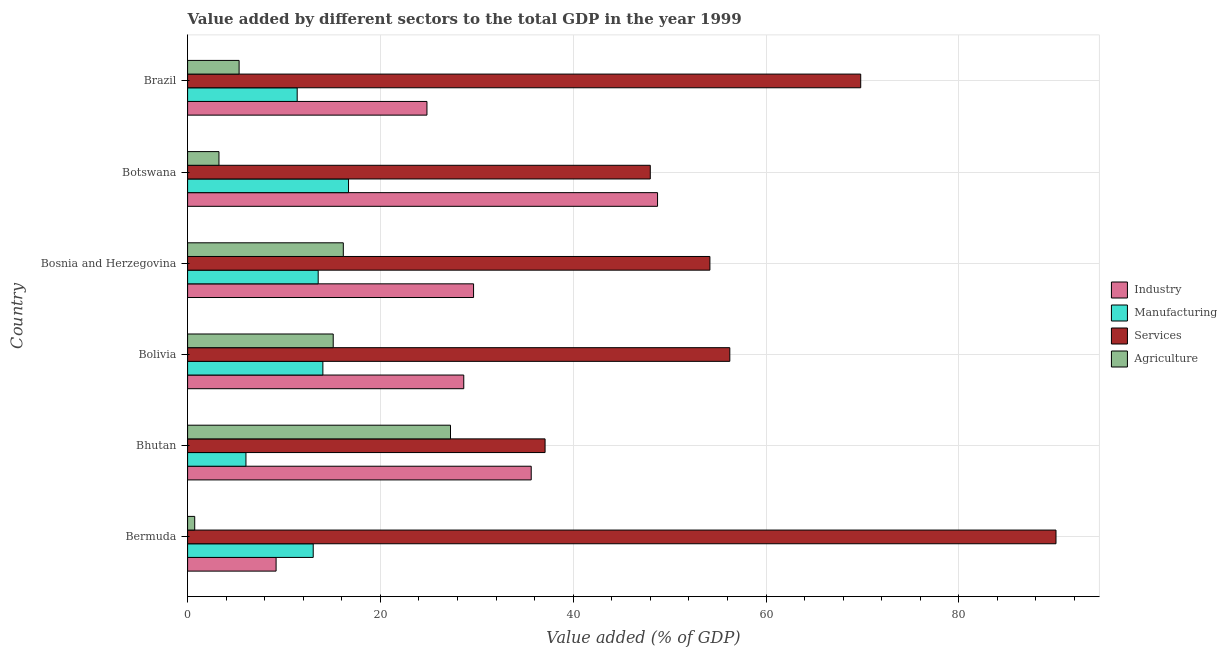How many different coloured bars are there?
Provide a short and direct response. 4. How many groups of bars are there?
Offer a terse response. 6. Are the number of bars on each tick of the Y-axis equal?
Provide a succinct answer. Yes. How many bars are there on the 3rd tick from the top?
Your answer should be compact. 4. What is the label of the 6th group of bars from the top?
Your response must be concise. Bermuda. In how many cases, is the number of bars for a given country not equal to the number of legend labels?
Ensure brevity in your answer.  0. What is the value added by services sector in Bermuda?
Give a very brief answer. 90.08. Across all countries, what is the maximum value added by industrial sector?
Your response must be concise. 48.75. Across all countries, what is the minimum value added by services sector?
Your response must be concise. 37.08. In which country was the value added by industrial sector maximum?
Offer a terse response. Botswana. In which country was the value added by industrial sector minimum?
Your response must be concise. Bermuda. What is the total value added by services sector in the graph?
Your response must be concise. 355.41. What is the difference between the value added by manufacturing sector in Bermuda and that in Brazil?
Offer a terse response. 1.66. What is the difference between the value added by industrial sector in Botswana and the value added by manufacturing sector in Bhutan?
Offer a very short reply. 42.7. What is the average value added by manufacturing sector per country?
Offer a very short reply. 12.46. What is the difference between the value added by industrial sector and value added by manufacturing sector in Brazil?
Provide a short and direct response. 13.46. What is the ratio of the value added by agricultural sector in Bhutan to that in Brazil?
Your answer should be compact. 5.1. What is the difference between the highest and the second highest value added by industrial sector?
Offer a very short reply. 13.11. What is the difference between the highest and the lowest value added by agricultural sector?
Your answer should be very brief. 26.53. In how many countries, is the value added by industrial sector greater than the average value added by industrial sector taken over all countries?
Provide a short and direct response. 3. Is the sum of the value added by services sector in Bhutan and Bolivia greater than the maximum value added by industrial sector across all countries?
Keep it short and to the point. Yes. Is it the case that in every country, the sum of the value added by services sector and value added by agricultural sector is greater than the sum of value added by industrial sector and value added by manufacturing sector?
Provide a succinct answer. Yes. What does the 1st bar from the top in Bermuda represents?
Provide a short and direct response. Agriculture. What does the 2nd bar from the bottom in Bhutan represents?
Provide a short and direct response. Manufacturing. Are all the bars in the graph horizontal?
Your answer should be very brief. Yes. How many countries are there in the graph?
Offer a very short reply. 6. Are the values on the major ticks of X-axis written in scientific E-notation?
Your answer should be very brief. No. Does the graph contain any zero values?
Your answer should be compact. No. Does the graph contain grids?
Ensure brevity in your answer.  Yes. How are the legend labels stacked?
Provide a short and direct response. Vertical. What is the title of the graph?
Your response must be concise. Value added by different sectors to the total GDP in the year 1999. What is the label or title of the X-axis?
Your answer should be very brief. Value added (% of GDP). What is the Value added (% of GDP) in Industry in Bermuda?
Make the answer very short. 9.18. What is the Value added (% of GDP) in Manufacturing in Bermuda?
Offer a very short reply. 13.03. What is the Value added (% of GDP) in Services in Bermuda?
Provide a succinct answer. 90.08. What is the Value added (% of GDP) of Agriculture in Bermuda?
Make the answer very short. 0.74. What is the Value added (% of GDP) in Industry in Bhutan?
Make the answer very short. 35.65. What is the Value added (% of GDP) in Manufacturing in Bhutan?
Make the answer very short. 6.05. What is the Value added (% of GDP) of Services in Bhutan?
Offer a very short reply. 37.08. What is the Value added (% of GDP) of Agriculture in Bhutan?
Your answer should be very brief. 27.27. What is the Value added (% of GDP) of Industry in Bolivia?
Make the answer very short. 28.65. What is the Value added (% of GDP) of Manufacturing in Bolivia?
Offer a very short reply. 14.03. What is the Value added (% of GDP) of Services in Bolivia?
Your answer should be compact. 56.25. What is the Value added (% of GDP) of Agriculture in Bolivia?
Offer a very short reply. 15.11. What is the Value added (% of GDP) in Industry in Bosnia and Herzegovina?
Make the answer very short. 29.66. What is the Value added (% of GDP) of Manufacturing in Bosnia and Herzegovina?
Your response must be concise. 13.55. What is the Value added (% of GDP) in Services in Bosnia and Herzegovina?
Offer a terse response. 54.18. What is the Value added (% of GDP) in Agriculture in Bosnia and Herzegovina?
Provide a short and direct response. 16.15. What is the Value added (% of GDP) of Industry in Botswana?
Provide a succinct answer. 48.75. What is the Value added (% of GDP) of Manufacturing in Botswana?
Offer a terse response. 16.69. What is the Value added (% of GDP) of Services in Botswana?
Make the answer very short. 48. What is the Value added (% of GDP) of Agriculture in Botswana?
Offer a terse response. 3.25. What is the Value added (% of GDP) in Industry in Brazil?
Provide a succinct answer. 24.83. What is the Value added (% of GDP) in Manufacturing in Brazil?
Give a very brief answer. 11.37. What is the Value added (% of GDP) in Services in Brazil?
Your answer should be very brief. 69.83. What is the Value added (% of GDP) of Agriculture in Brazil?
Your response must be concise. 5.34. Across all countries, what is the maximum Value added (% of GDP) of Industry?
Offer a very short reply. 48.75. Across all countries, what is the maximum Value added (% of GDP) of Manufacturing?
Provide a short and direct response. 16.69. Across all countries, what is the maximum Value added (% of GDP) of Services?
Your answer should be very brief. 90.08. Across all countries, what is the maximum Value added (% of GDP) of Agriculture?
Provide a short and direct response. 27.27. Across all countries, what is the minimum Value added (% of GDP) in Industry?
Provide a succinct answer. 9.18. Across all countries, what is the minimum Value added (% of GDP) of Manufacturing?
Offer a very short reply. 6.05. Across all countries, what is the minimum Value added (% of GDP) of Services?
Make the answer very short. 37.08. Across all countries, what is the minimum Value added (% of GDP) in Agriculture?
Offer a terse response. 0.74. What is the total Value added (% of GDP) of Industry in the graph?
Your response must be concise. 176.72. What is the total Value added (% of GDP) in Manufacturing in the graph?
Your response must be concise. 74.73. What is the total Value added (% of GDP) of Services in the graph?
Offer a very short reply. 355.41. What is the total Value added (% of GDP) of Agriculture in the graph?
Give a very brief answer. 67.87. What is the difference between the Value added (% of GDP) of Industry in Bermuda and that in Bhutan?
Provide a succinct answer. -26.47. What is the difference between the Value added (% of GDP) in Manufacturing in Bermuda and that in Bhutan?
Provide a succinct answer. 6.98. What is the difference between the Value added (% of GDP) of Services in Bermuda and that in Bhutan?
Ensure brevity in your answer.  53. What is the difference between the Value added (% of GDP) in Agriculture in Bermuda and that in Bhutan?
Your answer should be very brief. -26.53. What is the difference between the Value added (% of GDP) in Industry in Bermuda and that in Bolivia?
Provide a succinct answer. -19.47. What is the difference between the Value added (% of GDP) in Manufacturing in Bermuda and that in Bolivia?
Offer a very short reply. -1. What is the difference between the Value added (% of GDP) in Services in Bermuda and that in Bolivia?
Keep it short and to the point. 33.84. What is the difference between the Value added (% of GDP) of Agriculture in Bermuda and that in Bolivia?
Keep it short and to the point. -14.37. What is the difference between the Value added (% of GDP) in Industry in Bermuda and that in Bosnia and Herzegovina?
Provide a short and direct response. -20.49. What is the difference between the Value added (% of GDP) in Manufacturing in Bermuda and that in Bosnia and Herzegovina?
Ensure brevity in your answer.  -0.51. What is the difference between the Value added (% of GDP) of Services in Bermuda and that in Bosnia and Herzegovina?
Provide a succinct answer. 35.9. What is the difference between the Value added (% of GDP) in Agriculture in Bermuda and that in Bosnia and Herzegovina?
Ensure brevity in your answer.  -15.41. What is the difference between the Value added (% of GDP) in Industry in Bermuda and that in Botswana?
Offer a very short reply. -39.57. What is the difference between the Value added (% of GDP) in Manufacturing in Bermuda and that in Botswana?
Keep it short and to the point. -3.66. What is the difference between the Value added (% of GDP) in Services in Bermuda and that in Botswana?
Give a very brief answer. 42.09. What is the difference between the Value added (% of GDP) in Agriculture in Bermuda and that in Botswana?
Offer a terse response. -2.52. What is the difference between the Value added (% of GDP) in Industry in Bermuda and that in Brazil?
Your response must be concise. -15.65. What is the difference between the Value added (% of GDP) of Manufacturing in Bermuda and that in Brazil?
Provide a succinct answer. 1.66. What is the difference between the Value added (% of GDP) in Services in Bermuda and that in Brazil?
Your answer should be very brief. 20.26. What is the difference between the Value added (% of GDP) in Agriculture in Bermuda and that in Brazil?
Offer a very short reply. -4.61. What is the difference between the Value added (% of GDP) in Industry in Bhutan and that in Bolivia?
Give a very brief answer. 7. What is the difference between the Value added (% of GDP) in Manufacturing in Bhutan and that in Bolivia?
Keep it short and to the point. -7.98. What is the difference between the Value added (% of GDP) of Services in Bhutan and that in Bolivia?
Your answer should be very brief. -19.16. What is the difference between the Value added (% of GDP) in Agriculture in Bhutan and that in Bolivia?
Ensure brevity in your answer.  12.17. What is the difference between the Value added (% of GDP) in Industry in Bhutan and that in Bosnia and Herzegovina?
Your answer should be very brief. 5.98. What is the difference between the Value added (% of GDP) of Manufacturing in Bhutan and that in Bosnia and Herzegovina?
Make the answer very short. -7.49. What is the difference between the Value added (% of GDP) of Services in Bhutan and that in Bosnia and Herzegovina?
Your answer should be very brief. -17.1. What is the difference between the Value added (% of GDP) in Agriculture in Bhutan and that in Bosnia and Herzegovina?
Provide a short and direct response. 11.12. What is the difference between the Value added (% of GDP) of Industry in Bhutan and that in Botswana?
Your answer should be compact. -13.11. What is the difference between the Value added (% of GDP) in Manufacturing in Bhutan and that in Botswana?
Make the answer very short. -10.64. What is the difference between the Value added (% of GDP) in Services in Bhutan and that in Botswana?
Provide a succinct answer. -10.91. What is the difference between the Value added (% of GDP) of Agriculture in Bhutan and that in Botswana?
Ensure brevity in your answer.  24.02. What is the difference between the Value added (% of GDP) in Industry in Bhutan and that in Brazil?
Offer a very short reply. 10.82. What is the difference between the Value added (% of GDP) of Manufacturing in Bhutan and that in Brazil?
Offer a terse response. -5.32. What is the difference between the Value added (% of GDP) in Services in Bhutan and that in Brazil?
Your response must be concise. -32.74. What is the difference between the Value added (% of GDP) of Agriculture in Bhutan and that in Brazil?
Provide a succinct answer. 21.93. What is the difference between the Value added (% of GDP) in Industry in Bolivia and that in Bosnia and Herzegovina?
Provide a short and direct response. -1.02. What is the difference between the Value added (% of GDP) of Manufacturing in Bolivia and that in Bosnia and Herzegovina?
Provide a short and direct response. 0.49. What is the difference between the Value added (% of GDP) in Services in Bolivia and that in Bosnia and Herzegovina?
Your response must be concise. 2.06. What is the difference between the Value added (% of GDP) in Agriculture in Bolivia and that in Bosnia and Herzegovina?
Offer a very short reply. -1.05. What is the difference between the Value added (% of GDP) of Industry in Bolivia and that in Botswana?
Give a very brief answer. -20.1. What is the difference between the Value added (% of GDP) of Manufacturing in Bolivia and that in Botswana?
Offer a terse response. -2.66. What is the difference between the Value added (% of GDP) of Services in Bolivia and that in Botswana?
Your answer should be very brief. 8.25. What is the difference between the Value added (% of GDP) in Agriculture in Bolivia and that in Botswana?
Your answer should be compact. 11.85. What is the difference between the Value added (% of GDP) of Industry in Bolivia and that in Brazil?
Ensure brevity in your answer.  3.82. What is the difference between the Value added (% of GDP) in Manufacturing in Bolivia and that in Brazil?
Offer a very short reply. 2.66. What is the difference between the Value added (% of GDP) in Services in Bolivia and that in Brazil?
Ensure brevity in your answer.  -13.58. What is the difference between the Value added (% of GDP) of Agriculture in Bolivia and that in Brazil?
Make the answer very short. 9.76. What is the difference between the Value added (% of GDP) in Industry in Bosnia and Herzegovina and that in Botswana?
Your answer should be very brief. -19.09. What is the difference between the Value added (% of GDP) of Manufacturing in Bosnia and Herzegovina and that in Botswana?
Keep it short and to the point. -3.15. What is the difference between the Value added (% of GDP) in Services in Bosnia and Herzegovina and that in Botswana?
Your response must be concise. 6.19. What is the difference between the Value added (% of GDP) in Agriculture in Bosnia and Herzegovina and that in Botswana?
Provide a succinct answer. 12.9. What is the difference between the Value added (% of GDP) in Industry in Bosnia and Herzegovina and that in Brazil?
Your answer should be very brief. 4.83. What is the difference between the Value added (% of GDP) of Manufacturing in Bosnia and Herzegovina and that in Brazil?
Your response must be concise. 2.18. What is the difference between the Value added (% of GDP) in Services in Bosnia and Herzegovina and that in Brazil?
Give a very brief answer. -15.64. What is the difference between the Value added (% of GDP) in Agriculture in Bosnia and Herzegovina and that in Brazil?
Your response must be concise. 10.81. What is the difference between the Value added (% of GDP) in Industry in Botswana and that in Brazil?
Give a very brief answer. 23.92. What is the difference between the Value added (% of GDP) of Manufacturing in Botswana and that in Brazil?
Keep it short and to the point. 5.33. What is the difference between the Value added (% of GDP) in Services in Botswana and that in Brazil?
Ensure brevity in your answer.  -21.83. What is the difference between the Value added (% of GDP) of Agriculture in Botswana and that in Brazil?
Provide a short and direct response. -2.09. What is the difference between the Value added (% of GDP) in Industry in Bermuda and the Value added (% of GDP) in Manufacturing in Bhutan?
Your answer should be compact. 3.13. What is the difference between the Value added (% of GDP) of Industry in Bermuda and the Value added (% of GDP) of Services in Bhutan?
Ensure brevity in your answer.  -27.9. What is the difference between the Value added (% of GDP) of Industry in Bermuda and the Value added (% of GDP) of Agriculture in Bhutan?
Provide a short and direct response. -18.09. What is the difference between the Value added (% of GDP) of Manufacturing in Bermuda and the Value added (% of GDP) of Services in Bhutan?
Offer a very short reply. -24.05. What is the difference between the Value added (% of GDP) of Manufacturing in Bermuda and the Value added (% of GDP) of Agriculture in Bhutan?
Keep it short and to the point. -14.24. What is the difference between the Value added (% of GDP) of Services in Bermuda and the Value added (% of GDP) of Agriculture in Bhutan?
Your answer should be very brief. 62.81. What is the difference between the Value added (% of GDP) of Industry in Bermuda and the Value added (% of GDP) of Manufacturing in Bolivia?
Your response must be concise. -4.85. What is the difference between the Value added (% of GDP) of Industry in Bermuda and the Value added (% of GDP) of Services in Bolivia?
Provide a short and direct response. -47.07. What is the difference between the Value added (% of GDP) in Industry in Bermuda and the Value added (% of GDP) in Agriculture in Bolivia?
Provide a succinct answer. -5.93. What is the difference between the Value added (% of GDP) in Manufacturing in Bermuda and the Value added (% of GDP) in Services in Bolivia?
Your answer should be compact. -43.21. What is the difference between the Value added (% of GDP) of Manufacturing in Bermuda and the Value added (% of GDP) of Agriculture in Bolivia?
Offer a very short reply. -2.07. What is the difference between the Value added (% of GDP) of Services in Bermuda and the Value added (% of GDP) of Agriculture in Bolivia?
Give a very brief answer. 74.98. What is the difference between the Value added (% of GDP) in Industry in Bermuda and the Value added (% of GDP) in Manufacturing in Bosnia and Herzegovina?
Provide a succinct answer. -4.37. What is the difference between the Value added (% of GDP) in Industry in Bermuda and the Value added (% of GDP) in Services in Bosnia and Herzegovina?
Your answer should be compact. -45. What is the difference between the Value added (% of GDP) in Industry in Bermuda and the Value added (% of GDP) in Agriculture in Bosnia and Herzegovina?
Make the answer very short. -6.97. What is the difference between the Value added (% of GDP) of Manufacturing in Bermuda and the Value added (% of GDP) of Services in Bosnia and Herzegovina?
Keep it short and to the point. -41.15. What is the difference between the Value added (% of GDP) of Manufacturing in Bermuda and the Value added (% of GDP) of Agriculture in Bosnia and Herzegovina?
Your response must be concise. -3.12. What is the difference between the Value added (% of GDP) in Services in Bermuda and the Value added (% of GDP) in Agriculture in Bosnia and Herzegovina?
Give a very brief answer. 73.93. What is the difference between the Value added (% of GDP) in Industry in Bermuda and the Value added (% of GDP) in Manufacturing in Botswana?
Your response must be concise. -7.51. What is the difference between the Value added (% of GDP) in Industry in Bermuda and the Value added (% of GDP) in Services in Botswana?
Keep it short and to the point. -38.82. What is the difference between the Value added (% of GDP) of Industry in Bermuda and the Value added (% of GDP) of Agriculture in Botswana?
Keep it short and to the point. 5.93. What is the difference between the Value added (% of GDP) of Manufacturing in Bermuda and the Value added (% of GDP) of Services in Botswana?
Keep it short and to the point. -34.96. What is the difference between the Value added (% of GDP) in Manufacturing in Bermuda and the Value added (% of GDP) in Agriculture in Botswana?
Your answer should be compact. 9.78. What is the difference between the Value added (% of GDP) of Services in Bermuda and the Value added (% of GDP) of Agriculture in Botswana?
Provide a succinct answer. 86.83. What is the difference between the Value added (% of GDP) in Industry in Bermuda and the Value added (% of GDP) in Manufacturing in Brazil?
Give a very brief answer. -2.19. What is the difference between the Value added (% of GDP) of Industry in Bermuda and the Value added (% of GDP) of Services in Brazil?
Give a very brief answer. -60.65. What is the difference between the Value added (% of GDP) in Industry in Bermuda and the Value added (% of GDP) in Agriculture in Brazil?
Ensure brevity in your answer.  3.84. What is the difference between the Value added (% of GDP) in Manufacturing in Bermuda and the Value added (% of GDP) in Services in Brazil?
Offer a terse response. -56.79. What is the difference between the Value added (% of GDP) of Manufacturing in Bermuda and the Value added (% of GDP) of Agriculture in Brazil?
Keep it short and to the point. 7.69. What is the difference between the Value added (% of GDP) of Services in Bermuda and the Value added (% of GDP) of Agriculture in Brazil?
Offer a terse response. 84.74. What is the difference between the Value added (% of GDP) of Industry in Bhutan and the Value added (% of GDP) of Manufacturing in Bolivia?
Make the answer very short. 21.61. What is the difference between the Value added (% of GDP) of Industry in Bhutan and the Value added (% of GDP) of Services in Bolivia?
Give a very brief answer. -20.6. What is the difference between the Value added (% of GDP) in Industry in Bhutan and the Value added (% of GDP) in Agriculture in Bolivia?
Your answer should be very brief. 20.54. What is the difference between the Value added (% of GDP) in Manufacturing in Bhutan and the Value added (% of GDP) in Services in Bolivia?
Provide a short and direct response. -50.19. What is the difference between the Value added (% of GDP) of Manufacturing in Bhutan and the Value added (% of GDP) of Agriculture in Bolivia?
Your answer should be very brief. -9.05. What is the difference between the Value added (% of GDP) in Services in Bhutan and the Value added (% of GDP) in Agriculture in Bolivia?
Your answer should be very brief. 21.98. What is the difference between the Value added (% of GDP) in Industry in Bhutan and the Value added (% of GDP) in Manufacturing in Bosnia and Herzegovina?
Provide a succinct answer. 22.1. What is the difference between the Value added (% of GDP) in Industry in Bhutan and the Value added (% of GDP) in Services in Bosnia and Herzegovina?
Provide a succinct answer. -18.54. What is the difference between the Value added (% of GDP) of Industry in Bhutan and the Value added (% of GDP) of Agriculture in Bosnia and Herzegovina?
Offer a very short reply. 19.49. What is the difference between the Value added (% of GDP) in Manufacturing in Bhutan and the Value added (% of GDP) in Services in Bosnia and Herzegovina?
Make the answer very short. -48.13. What is the difference between the Value added (% of GDP) of Manufacturing in Bhutan and the Value added (% of GDP) of Agriculture in Bosnia and Herzegovina?
Offer a very short reply. -10.1. What is the difference between the Value added (% of GDP) of Services in Bhutan and the Value added (% of GDP) of Agriculture in Bosnia and Herzegovina?
Ensure brevity in your answer.  20.93. What is the difference between the Value added (% of GDP) of Industry in Bhutan and the Value added (% of GDP) of Manufacturing in Botswana?
Make the answer very short. 18.95. What is the difference between the Value added (% of GDP) in Industry in Bhutan and the Value added (% of GDP) in Services in Botswana?
Your answer should be compact. -12.35. What is the difference between the Value added (% of GDP) of Industry in Bhutan and the Value added (% of GDP) of Agriculture in Botswana?
Offer a terse response. 32.39. What is the difference between the Value added (% of GDP) of Manufacturing in Bhutan and the Value added (% of GDP) of Services in Botswana?
Offer a terse response. -41.94. What is the difference between the Value added (% of GDP) in Manufacturing in Bhutan and the Value added (% of GDP) in Agriculture in Botswana?
Your response must be concise. 2.8. What is the difference between the Value added (% of GDP) of Services in Bhutan and the Value added (% of GDP) of Agriculture in Botswana?
Make the answer very short. 33.83. What is the difference between the Value added (% of GDP) in Industry in Bhutan and the Value added (% of GDP) in Manufacturing in Brazil?
Make the answer very short. 24.28. What is the difference between the Value added (% of GDP) of Industry in Bhutan and the Value added (% of GDP) of Services in Brazil?
Keep it short and to the point. -34.18. What is the difference between the Value added (% of GDP) of Industry in Bhutan and the Value added (% of GDP) of Agriculture in Brazil?
Ensure brevity in your answer.  30.3. What is the difference between the Value added (% of GDP) of Manufacturing in Bhutan and the Value added (% of GDP) of Services in Brazil?
Give a very brief answer. -63.77. What is the difference between the Value added (% of GDP) of Manufacturing in Bhutan and the Value added (% of GDP) of Agriculture in Brazil?
Provide a succinct answer. 0.71. What is the difference between the Value added (% of GDP) of Services in Bhutan and the Value added (% of GDP) of Agriculture in Brazil?
Offer a very short reply. 31.74. What is the difference between the Value added (% of GDP) of Industry in Bolivia and the Value added (% of GDP) of Manufacturing in Bosnia and Herzegovina?
Give a very brief answer. 15.1. What is the difference between the Value added (% of GDP) in Industry in Bolivia and the Value added (% of GDP) in Services in Bosnia and Herzegovina?
Provide a succinct answer. -25.53. What is the difference between the Value added (% of GDP) in Industry in Bolivia and the Value added (% of GDP) in Agriculture in Bosnia and Herzegovina?
Keep it short and to the point. 12.5. What is the difference between the Value added (% of GDP) of Manufacturing in Bolivia and the Value added (% of GDP) of Services in Bosnia and Herzegovina?
Make the answer very short. -40.15. What is the difference between the Value added (% of GDP) in Manufacturing in Bolivia and the Value added (% of GDP) in Agriculture in Bosnia and Herzegovina?
Your answer should be very brief. -2.12. What is the difference between the Value added (% of GDP) in Services in Bolivia and the Value added (% of GDP) in Agriculture in Bosnia and Herzegovina?
Your answer should be very brief. 40.09. What is the difference between the Value added (% of GDP) in Industry in Bolivia and the Value added (% of GDP) in Manufacturing in Botswana?
Your answer should be very brief. 11.95. What is the difference between the Value added (% of GDP) of Industry in Bolivia and the Value added (% of GDP) of Services in Botswana?
Your answer should be very brief. -19.35. What is the difference between the Value added (% of GDP) in Industry in Bolivia and the Value added (% of GDP) in Agriculture in Botswana?
Offer a terse response. 25.39. What is the difference between the Value added (% of GDP) of Manufacturing in Bolivia and the Value added (% of GDP) of Services in Botswana?
Ensure brevity in your answer.  -33.96. What is the difference between the Value added (% of GDP) in Manufacturing in Bolivia and the Value added (% of GDP) in Agriculture in Botswana?
Offer a very short reply. 10.78. What is the difference between the Value added (% of GDP) of Services in Bolivia and the Value added (% of GDP) of Agriculture in Botswana?
Make the answer very short. 52.99. What is the difference between the Value added (% of GDP) in Industry in Bolivia and the Value added (% of GDP) in Manufacturing in Brazil?
Ensure brevity in your answer.  17.28. What is the difference between the Value added (% of GDP) in Industry in Bolivia and the Value added (% of GDP) in Services in Brazil?
Give a very brief answer. -41.18. What is the difference between the Value added (% of GDP) of Industry in Bolivia and the Value added (% of GDP) of Agriculture in Brazil?
Keep it short and to the point. 23.3. What is the difference between the Value added (% of GDP) of Manufacturing in Bolivia and the Value added (% of GDP) of Services in Brazil?
Offer a terse response. -55.79. What is the difference between the Value added (% of GDP) in Manufacturing in Bolivia and the Value added (% of GDP) in Agriculture in Brazil?
Ensure brevity in your answer.  8.69. What is the difference between the Value added (% of GDP) of Services in Bolivia and the Value added (% of GDP) of Agriculture in Brazil?
Give a very brief answer. 50.9. What is the difference between the Value added (% of GDP) of Industry in Bosnia and Herzegovina and the Value added (% of GDP) of Manufacturing in Botswana?
Keep it short and to the point. 12.97. What is the difference between the Value added (% of GDP) of Industry in Bosnia and Herzegovina and the Value added (% of GDP) of Services in Botswana?
Offer a terse response. -18.33. What is the difference between the Value added (% of GDP) of Industry in Bosnia and Herzegovina and the Value added (% of GDP) of Agriculture in Botswana?
Offer a very short reply. 26.41. What is the difference between the Value added (% of GDP) of Manufacturing in Bosnia and Herzegovina and the Value added (% of GDP) of Services in Botswana?
Give a very brief answer. -34.45. What is the difference between the Value added (% of GDP) in Manufacturing in Bosnia and Herzegovina and the Value added (% of GDP) in Agriculture in Botswana?
Provide a short and direct response. 10.29. What is the difference between the Value added (% of GDP) in Services in Bosnia and Herzegovina and the Value added (% of GDP) in Agriculture in Botswana?
Offer a terse response. 50.93. What is the difference between the Value added (% of GDP) in Industry in Bosnia and Herzegovina and the Value added (% of GDP) in Manufacturing in Brazil?
Your response must be concise. 18.3. What is the difference between the Value added (% of GDP) in Industry in Bosnia and Herzegovina and the Value added (% of GDP) in Services in Brazil?
Ensure brevity in your answer.  -40.16. What is the difference between the Value added (% of GDP) in Industry in Bosnia and Herzegovina and the Value added (% of GDP) in Agriculture in Brazil?
Make the answer very short. 24.32. What is the difference between the Value added (% of GDP) of Manufacturing in Bosnia and Herzegovina and the Value added (% of GDP) of Services in Brazil?
Ensure brevity in your answer.  -56.28. What is the difference between the Value added (% of GDP) in Manufacturing in Bosnia and Herzegovina and the Value added (% of GDP) in Agriculture in Brazil?
Provide a succinct answer. 8.2. What is the difference between the Value added (% of GDP) in Services in Bosnia and Herzegovina and the Value added (% of GDP) in Agriculture in Brazil?
Offer a terse response. 48.84. What is the difference between the Value added (% of GDP) of Industry in Botswana and the Value added (% of GDP) of Manufacturing in Brazil?
Ensure brevity in your answer.  37.38. What is the difference between the Value added (% of GDP) in Industry in Botswana and the Value added (% of GDP) in Services in Brazil?
Make the answer very short. -21.08. What is the difference between the Value added (% of GDP) of Industry in Botswana and the Value added (% of GDP) of Agriculture in Brazil?
Your answer should be very brief. 43.41. What is the difference between the Value added (% of GDP) in Manufacturing in Botswana and the Value added (% of GDP) in Services in Brazil?
Offer a terse response. -53.13. What is the difference between the Value added (% of GDP) of Manufacturing in Botswana and the Value added (% of GDP) of Agriculture in Brazil?
Ensure brevity in your answer.  11.35. What is the difference between the Value added (% of GDP) of Services in Botswana and the Value added (% of GDP) of Agriculture in Brazil?
Provide a short and direct response. 42.65. What is the average Value added (% of GDP) in Industry per country?
Keep it short and to the point. 29.45. What is the average Value added (% of GDP) of Manufacturing per country?
Your response must be concise. 12.45. What is the average Value added (% of GDP) of Services per country?
Give a very brief answer. 59.24. What is the average Value added (% of GDP) of Agriculture per country?
Your answer should be very brief. 11.31. What is the difference between the Value added (% of GDP) of Industry and Value added (% of GDP) of Manufacturing in Bermuda?
Provide a succinct answer. -3.85. What is the difference between the Value added (% of GDP) in Industry and Value added (% of GDP) in Services in Bermuda?
Provide a short and direct response. -80.9. What is the difference between the Value added (% of GDP) in Industry and Value added (% of GDP) in Agriculture in Bermuda?
Your response must be concise. 8.44. What is the difference between the Value added (% of GDP) of Manufacturing and Value added (% of GDP) of Services in Bermuda?
Offer a terse response. -77.05. What is the difference between the Value added (% of GDP) in Manufacturing and Value added (% of GDP) in Agriculture in Bermuda?
Offer a very short reply. 12.29. What is the difference between the Value added (% of GDP) of Services and Value added (% of GDP) of Agriculture in Bermuda?
Offer a terse response. 89.34. What is the difference between the Value added (% of GDP) in Industry and Value added (% of GDP) in Manufacturing in Bhutan?
Offer a terse response. 29.59. What is the difference between the Value added (% of GDP) of Industry and Value added (% of GDP) of Services in Bhutan?
Give a very brief answer. -1.44. What is the difference between the Value added (% of GDP) of Industry and Value added (% of GDP) of Agriculture in Bhutan?
Your response must be concise. 8.37. What is the difference between the Value added (% of GDP) of Manufacturing and Value added (% of GDP) of Services in Bhutan?
Provide a succinct answer. -31.03. What is the difference between the Value added (% of GDP) of Manufacturing and Value added (% of GDP) of Agriculture in Bhutan?
Make the answer very short. -21.22. What is the difference between the Value added (% of GDP) in Services and Value added (% of GDP) in Agriculture in Bhutan?
Offer a very short reply. 9.81. What is the difference between the Value added (% of GDP) of Industry and Value added (% of GDP) of Manufacturing in Bolivia?
Ensure brevity in your answer.  14.62. What is the difference between the Value added (% of GDP) of Industry and Value added (% of GDP) of Services in Bolivia?
Your response must be concise. -27.6. What is the difference between the Value added (% of GDP) in Industry and Value added (% of GDP) in Agriculture in Bolivia?
Your answer should be very brief. 13.54. What is the difference between the Value added (% of GDP) of Manufacturing and Value added (% of GDP) of Services in Bolivia?
Your answer should be very brief. -42.21. What is the difference between the Value added (% of GDP) of Manufacturing and Value added (% of GDP) of Agriculture in Bolivia?
Keep it short and to the point. -1.07. What is the difference between the Value added (% of GDP) of Services and Value added (% of GDP) of Agriculture in Bolivia?
Provide a short and direct response. 41.14. What is the difference between the Value added (% of GDP) in Industry and Value added (% of GDP) in Manufacturing in Bosnia and Herzegovina?
Ensure brevity in your answer.  16.12. What is the difference between the Value added (% of GDP) in Industry and Value added (% of GDP) in Services in Bosnia and Herzegovina?
Offer a terse response. -24.52. What is the difference between the Value added (% of GDP) of Industry and Value added (% of GDP) of Agriculture in Bosnia and Herzegovina?
Make the answer very short. 13.51. What is the difference between the Value added (% of GDP) in Manufacturing and Value added (% of GDP) in Services in Bosnia and Herzegovina?
Give a very brief answer. -40.63. What is the difference between the Value added (% of GDP) of Manufacturing and Value added (% of GDP) of Agriculture in Bosnia and Herzegovina?
Offer a very short reply. -2.61. What is the difference between the Value added (% of GDP) in Services and Value added (% of GDP) in Agriculture in Bosnia and Herzegovina?
Offer a terse response. 38.03. What is the difference between the Value added (% of GDP) in Industry and Value added (% of GDP) in Manufacturing in Botswana?
Your response must be concise. 32.06. What is the difference between the Value added (% of GDP) in Industry and Value added (% of GDP) in Services in Botswana?
Your answer should be very brief. 0.75. What is the difference between the Value added (% of GDP) of Industry and Value added (% of GDP) of Agriculture in Botswana?
Provide a short and direct response. 45.5. What is the difference between the Value added (% of GDP) in Manufacturing and Value added (% of GDP) in Services in Botswana?
Keep it short and to the point. -31.3. What is the difference between the Value added (% of GDP) in Manufacturing and Value added (% of GDP) in Agriculture in Botswana?
Offer a very short reply. 13.44. What is the difference between the Value added (% of GDP) of Services and Value added (% of GDP) of Agriculture in Botswana?
Make the answer very short. 44.74. What is the difference between the Value added (% of GDP) of Industry and Value added (% of GDP) of Manufacturing in Brazil?
Your answer should be very brief. 13.46. What is the difference between the Value added (% of GDP) of Industry and Value added (% of GDP) of Services in Brazil?
Your answer should be compact. -45. What is the difference between the Value added (% of GDP) of Industry and Value added (% of GDP) of Agriculture in Brazil?
Give a very brief answer. 19.49. What is the difference between the Value added (% of GDP) of Manufacturing and Value added (% of GDP) of Services in Brazil?
Provide a succinct answer. -58.46. What is the difference between the Value added (% of GDP) in Manufacturing and Value added (% of GDP) in Agriculture in Brazil?
Provide a succinct answer. 6.02. What is the difference between the Value added (% of GDP) in Services and Value added (% of GDP) in Agriculture in Brazil?
Your answer should be very brief. 64.48. What is the ratio of the Value added (% of GDP) in Industry in Bermuda to that in Bhutan?
Give a very brief answer. 0.26. What is the ratio of the Value added (% of GDP) of Manufacturing in Bermuda to that in Bhutan?
Your answer should be compact. 2.15. What is the ratio of the Value added (% of GDP) of Services in Bermuda to that in Bhutan?
Your answer should be very brief. 2.43. What is the ratio of the Value added (% of GDP) in Agriculture in Bermuda to that in Bhutan?
Provide a short and direct response. 0.03. What is the ratio of the Value added (% of GDP) in Industry in Bermuda to that in Bolivia?
Provide a succinct answer. 0.32. What is the ratio of the Value added (% of GDP) in Manufacturing in Bermuda to that in Bolivia?
Your answer should be compact. 0.93. What is the ratio of the Value added (% of GDP) in Services in Bermuda to that in Bolivia?
Provide a short and direct response. 1.6. What is the ratio of the Value added (% of GDP) of Agriculture in Bermuda to that in Bolivia?
Give a very brief answer. 0.05. What is the ratio of the Value added (% of GDP) in Industry in Bermuda to that in Bosnia and Herzegovina?
Offer a terse response. 0.31. What is the ratio of the Value added (% of GDP) of Manufacturing in Bermuda to that in Bosnia and Herzegovina?
Keep it short and to the point. 0.96. What is the ratio of the Value added (% of GDP) in Services in Bermuda to that in Bosnia and Herzegovina?
Give a very brief answer. 1.66. What is the ratio of the Value added (% of GDP) of Agriculture in Bermuda to that in Bosnia and Herzegovina?
Offer a terse response. 0.05. What is the ratio of the Value added (% of GDP) of Industry in Bermuda to that in Botswana?
Your response must be concise. 0.19. What is the ratio of the Value added (% of GDP) of Manufacturing in Bermuda to that in Botswana?
Provide a succinct answer. 0.78. What is the ratio of the Value added (% of GDP) in Services in Bermuda to that in Botswana?
Your answer should be very brief. 1.88. What is the ratio of the Value added (% of GDP) of Agriculture in Bermuda to that in Botswana?
Provide a succinct answer. 0.23. What is the ratio of the Value added (% of GDP) in Industry in Bermuda to that in Brazil?
Give a very brief answer. 0.37. What is the ratio of the Value added (% of GDP) of Manufacturing in Bermuda to that in Brazil?
Your answer should be compact. 1.15. What is the ratio of the Value added (% of GDP) in Services in Bermuda to that in Brazil?
Make the answer very short. 1.29. What is the ratio of the Value added (% of GDP) in Agriculture in Bermuda to that in Brazil?
Provide a succinct answer. 0.14. What is the ratio of the Value added (% of GDP) of Industry in Bhutan to that in Bolivia?
Provide a succinct answer. 1.24. What is the ratio of the Value added (% of GDP) in Manufacturing in Bhutan to that in Bolivia?
Provide a succinct answer. 0.43. What is the ratio of the Value added (% of GDP) of Services in Bhutan to that in Bolivia?
Offer a terse response. 0.66. What is the ratio of the Value added (% of GDP) of Agriculture in Bhutan to that in Bolivia?
Offer a terse response. 1.81. What is the ratio of the Value added (% of GDP) of Industry in Bhutan to that in Bosnia and Herzegovina?
Your response must be concise. 1.2. What is the ratio of the Value added (% of GDP) in Manufacturing in Bhutan to that in Bosnia and Herzegovina?
Give a very brief answer. 0.45. What is the ratio of the Value added (% of GDP) in Services in Bhutan to that in Bosnia and Herzegovina?
Make the answer very short. 0.68. What is the ratio of the Value added (% of GDP) of Agriculture in Bhutan to that in Bosnia and Herzegovina?
Provide a succinct answer. 1.69. What is the ratio of the Value added (% of GDP) of Industry in Bhutan to that in Botswana?
Your response must be concise. 0.73. What is the ratio of the Value added (% of GDP) of Manufacturing in Bhutan to that in Botswana?
Offer a terse response. 0.36. What is the ratio of the Value added (% of GDP) in Services in Bhutan to that in Botswana?
Your response must be concise. 0.77. What is the ratio of the Value added (% of GDP) in Agriculture in Bhutan to that in Botswana?
Offer a very short reply. 8.38. What is the ratio of the Value added (% of GDP) in Industry in Bhutan to that in Brazil?
Provide a short and direct response. 1.44. What is the ratio of the Value added (% of GDP) in Manufacturing in Bhutan to that in Brazil?
Offer a terse response. 0.53. What is the ratio of the Value added (% of GDP) in Services in Bhutan to that in Brazil?
Give a very brief answer. 0.53. What is the ratio of the Value added (% of GDP) in Agriculture in Bhutan to that in Brazil?
Offer a very short reply. 5.1. What is the ratio of the Value added (% of GDP) of Industry in Bolivia to that in Bosnia and Herzegovina?
Provide a short and direct response. 0.97. What is the ratio of the Value added (% of GDP) of Manufacturing in Bolivia to that in Bosnia and Herzegovina?
Your answer should be very brief. 1.04. What is the ratio of the Value added (% of GDP) in Services in Bolivia to that in Bosnia and Herzegovina?
Provide a short and direct response. 1.04. What is the ratio of the Value added (% of GDP) in Agriculture in Bolivia to that in Bosnia and Herzegovina?
Ensure brevity in your answer.  0.94. What is the ratio of the Value added (% of GDP) in Industry in Bolivia to that in Botswana?
Make the answer very short. 0.59. What is the ratio of the Value added (% of GDP) in Manufacturing in Bolivia to that in Botswana?
Your answer should be compact. 0.84. What is the ratio of the Value added (% of GDP) in Services in Bolivia to that in Botswana?
Offer a terse response. 1.17. What is the ratio of the Value added (% of GDP) in Agriculture in Bolivia to that in Botswana?
Your answer should be compact. 4.64. What is the ratio of the Value added (% of GDP) of Industry in Bolivia to that in Brazil?
Give a very brief answer. 1.15. What is the ratio of the Value added (% of GDP) in Manufacturing in Bolivia to that in Brazil?
Provide a short and direct response. 1.23. What is the ratio of the Value added (% of GDP) in Services in Bolivia to that in Brazil?
Offer a terse response. 0.81. What is the ratio of the Value added (% of GDP) of Agriculture in Bolivia to that in Brazil?
Offer a very short reply. 2.83. What is the ratio of the Value added (% of GDP) of Industry in Bosnia and Herzegovina to that in Botswana?
Give a very brief answer. 0.61. What is the ratio of the Value added (% of GDP) of Manufacturing in Bosnia and Herzegovina to that in Botswana?
Your response must be concise. 0.81. What is the ratio of the Value added (% of GDP) of Services in Bosnia and Herzegovina to that in Botswana?
Your answer should be compact. 1.13. What is the ratio of the Value added (% of GDP) in Agriculture in Bosnia and Herzegovina to that in Botswana?
Provide a succinct answer. 4.96. What is the ratio of the Value added (% of GDP) in Industry in Bosnia and Herzegovina to that in Brazil?
Offer a terse response. 1.19. What is the ratio of the Value added (% of GDP) in Manufacturing in Bosnia and Herzegovina to that in Brazil?
Keep it short and to the point. 1.19. What is the ratio of the Value added (% of GDP) in Services in Bosnia and Herzegovina to that in Brazil?
Give a very brief answer. 0.78. What is the ratio of the Value added (% of GDP) in Agriculture in Bosnia and Herzegovina to that in Brazil?
Offer a very short reply. 3.02. What is the ratio of the Value added (% of GDP) in Industry in Botswana to that in Brazil?
Provide a succinct answer. 1.96. What is the ratio of the Value added (% of GDP) of Manufacturing in Botswana to that in Brazil?
Give a very brief answer. 1.47. What is the ratio of the Value added (% of GDP) in Services in Botswana to that in Brazil?
Make the answer very short. 0.69. What is the ratio of the Value added (% of GDP) of Agriculture in Botswana to that in Brazil?
Your answer should be very brief. 0.61. What is the difference between the highest and the second highest Value added (% of GDP) in Industry?
Offer a terse response. 13.11. What is the difference between the highest and the second highest Value added (% of GDP) in Manufacturing?
Make the answer very short. 2.66. What is the difference between the highest and the second highest Value added (% of GDP) of Services?
Give a very brief answer. 20.26. What is the difference between the highest and the second highest Value added (% of GDP) of Agriculture?
Your answer should be compact. 11.12. What is the difference between the highest and the lowest Value added (% of GDP) of Industry?
Your answer should be compact. 39.57. What is the difference between the highest and the lowest Value added (% of GDP) in Manufacturing?
Offer a very short reply. 10.64. What is the difference between the highest and the lowest Value added (% of GDP) in Services?
Offer a terse response. 53. What is the difference between the highest and the lowest Value added (% of GDP) in Agriculture?
Provide a short and direct response. 26.53. 